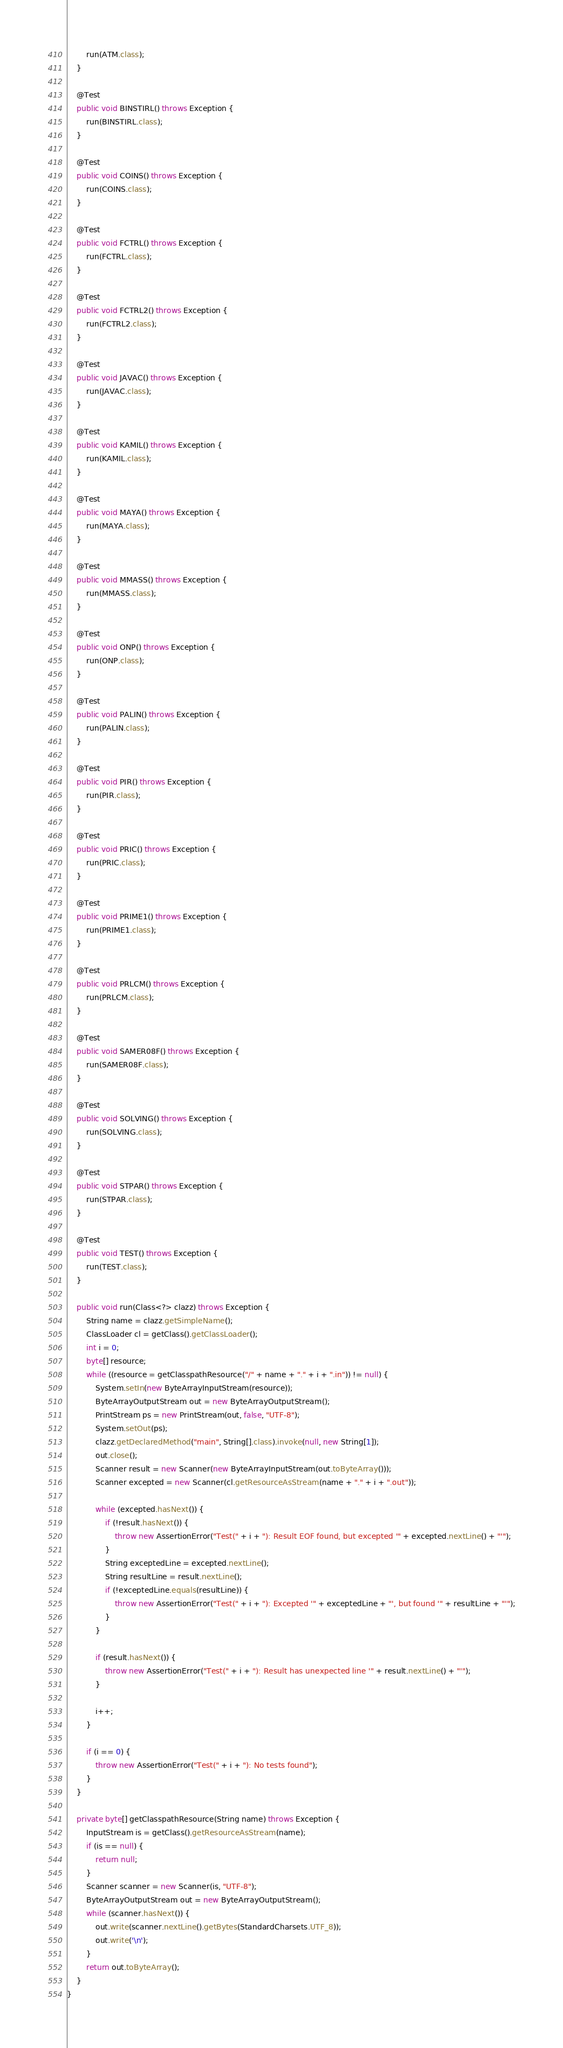<code> <loc_0><loc_0><loc_500><loc_500><_Java_>        run(ATM.class);
    }

    @Test
    public void BINSTIRL() throws Exception {
        run(BINSTIRL.class);
    }

    @Test
    public void COINS() throws Exception {
        run(COINS.class);
    }

    @Test
    public void FCTRL() throws Exception {
        run(FCTRL.class);
    }

    @Test
    public void FCTRL2() throws Exception {
        run(FCTRL2.class);
    }

    @Test
    public void JAVAC() throws Exception {
        run(JAVAC.class);
    }

    @Test
    public void KAMIL() throws Exception {
        run(KAMIL.class);
    }

    @Test
    public void MAYA() throws Exception {
        run(MAYA.class);
    }

    @Test
    public void MMASS() throws Exception {
        run(MMASS.class);
    }

    @Test
    public void ONP() throws Exception {
        run(ONP.class);
    }

    @Test
    public void PALIN() throws Exception {
        run(PALIN.class);
    }

    @Test
    public void PIR() throws Exception {
        run(PIR.class);
    }

    @Test
    public void PRIC() throws Exception {
        run(PRIC.class);
    }

    @Test
    public void PRIME1() throws Exception {
        run(PRIME1.class);
    }

    @Test
    public void PRLCM() throws Exception {
        run(PRLCM.class);
    }

    @Test
    public void SAMER08F() throws Exception {
        run(SAMER08F.class);
    }

    @Test
    public void SOLVING() throws Exception {
        run(SOLVING.class);
    }

    @Test
    public void STPAR() throws Exception {
        run(STPAR.class);
    }

    @Test
    public void TEST() throws Exception {
        run(TEST.class);
    }

    public void run(Class<?> clazz) throws Exception {
        String name = clazz.getSimpleName();
        ClassLoader cl = getClass().getClassLoader();
        int i = 0;
        byte[] resource;
        while ((resource = getClasspathResource("/" + name + "." + i + ".in")) != null) {
            System.setIn(new ByteArrayInputStream(resource));
            ByteArrayOutputStream out = new ByteArrayOutputStream();
            PrintStream ps = new PrintStream(out, false, "UTF-8");
            System.setOut(ps);
            clazz.getDeclaredMethod("main", String[].class).invoke(null, new String[1]);
            out.close();
            Scanner result = new Scanner(new ByteArrayInputStream(out.toByteArray()));
            Scanner excepted = new Scanner(cl.getResourceAsStream(name + "." + i + ".out"));

            while (excepted.hasNext()) {
                if (!result.hasNext()) {
                    throw new AssertionError("Test(" + i + "): Result EOF found, but excepted '" + excepted.nextLine() + "'");
                }
                String exceptedLine = excepted.nextLine();
                String resultLine = result.nextLine();
                if (!exceptedLine.equals(resultLine)) {
                    throw new AssertionError("Test(" + i + "): Excepted '" + exceptedLine + "', but found '" + resultLine + "'");
                }
            }

            if (result.hasNext()) {
                throw new AssertionError("Test(" + i + "): Result has unexpected line '" + result.nextLine() + "'");
            }

            i++;
        }

        if (i == 0) {
            throw new AssertionError("Test(" + i + "): No tests found");
        }
    }

    private byte[] getClasspathResource(String name) throws Exception {
        InputStream is = getClass().getResourceAsStream(name);
        if (is == null) {
            return null;
        }
        Scanner scanner = new Scanner(is, "UTF-8");
        ByteArrayOutputStream out = new ByteArrayOutputStream();
        while (scanner.hasNext()) {
            out.write(scanner.nextLine().getBytes(StandardCharsets.UTF_8));
            out.write('\n');
        }
        return out.toByteArray();
    }
}
</code> 